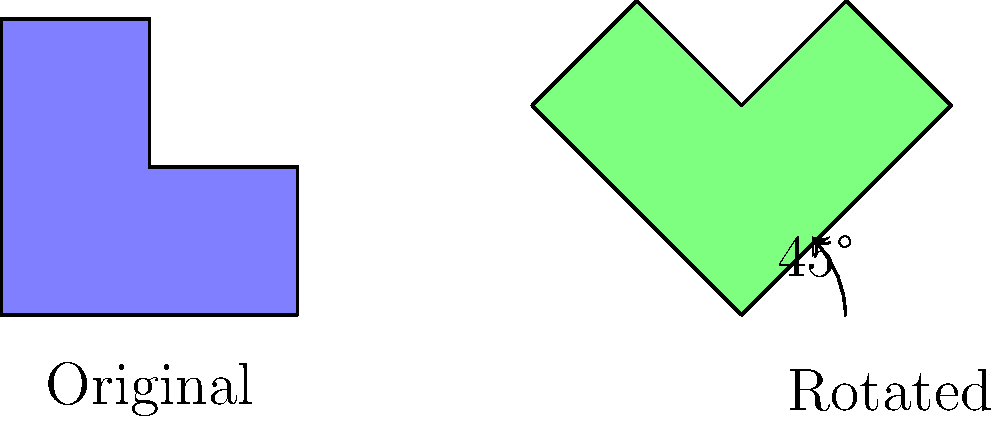In your data analytics software UI, you need to implement a feature that rotates a complex 2D shape representing a menu icon. The original shape is an L-shaped polygon, and it needs to be rotated 45 degrees clockwise. If the original shape has a width of 2 units and a height of 2 units, what will be the approximate width and height of the bounding box that contains the rotated shape? To solve this problem, we need to follow these steps:

1. Understand the original shape:
   The original shape is an L-shaped polygon with width 2 units and height 2 units.

2. Visualize the rotation:
   The shape is rotated 45 degrees clockwise around its bottom-left corner.

3. Calculate the new dimensions:
   To find the dimensions of the bounding box after rotation, we can use the formula for the diagonal of a square:
   
   Diagonal = $\sqrt{width^2 + height^2}$
   
   In this case, $\sqrt{2^2 + 2^2} = \sqrt{8} \approx 2.83$ units

4. The rotated shape will fit inside a square bounding box:
   When a square is rotated 45 degrees, its diagonal becomes the new width and height of the bounding box.

5. Therefore, both the width and height of the new bounding box will be approximately 2.83 units.

This calculation provides the dimensions of the smallest square that can contain the rotated L-shaped polygon.
Answer: $2.83 \times 2.83$ units 